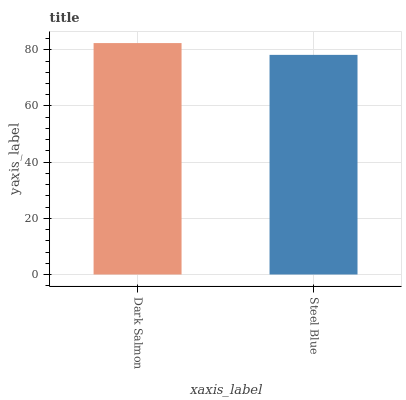Is Steel Blue the minimum?
Answer yes or no. Yes. Is Dark Salmon the maximum?
Answer yes or no. Yes. Is Steel Blue the maximum?
Answer yes or no. No. Is Dark Salmon greater than Steel Blue?
Answer yes or no. Yes. Is Steel Blue less than Dark Salmon?
Answer yes or no. Yes. Is Steel Blue greater than Dark Salmon?
Answer yes or no. No. Is Dark Salmon less than Steel Blue?
Answer yes or no. No. Is Dark Salmon the high median?
Answer yes or no. Yes. Is Steel Blue the low median?
Answer yes or no. Yes. Is Steel Blue the high median?
Answer yes or no. No. Is Dark Salmon the low median?
Answer yes or no. No. 